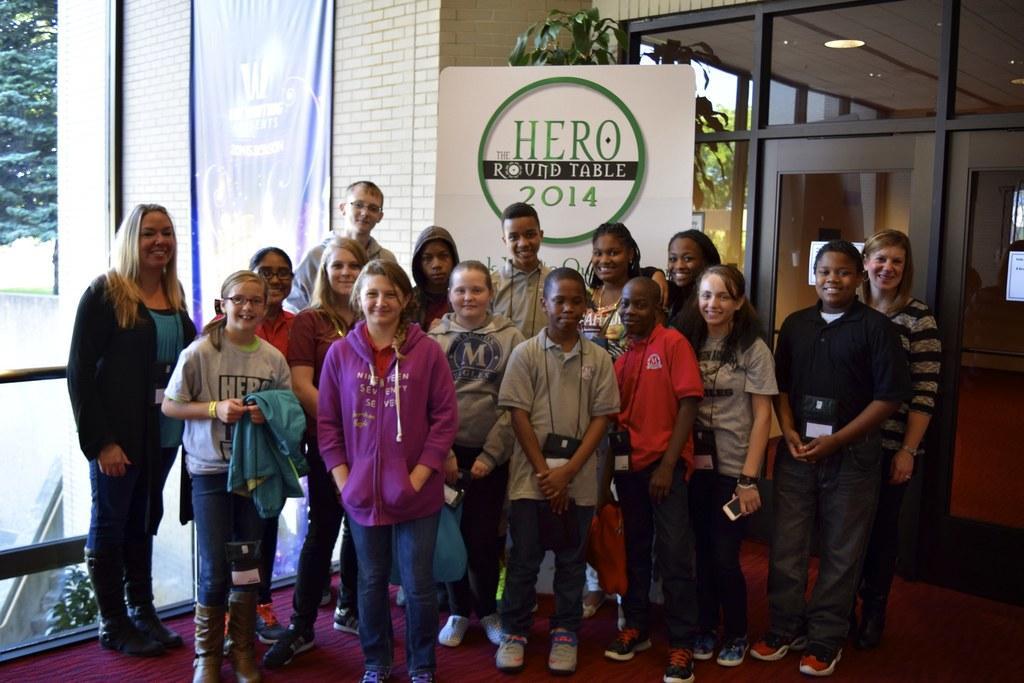Can you describe this image briefly? In this picture we can see group of boys and girls standing and giving pose into the photograph. Behind we can see roller poster on which "Hero Round Table 2014" is written. In the background we can see brick color white wall and a big glass door. 